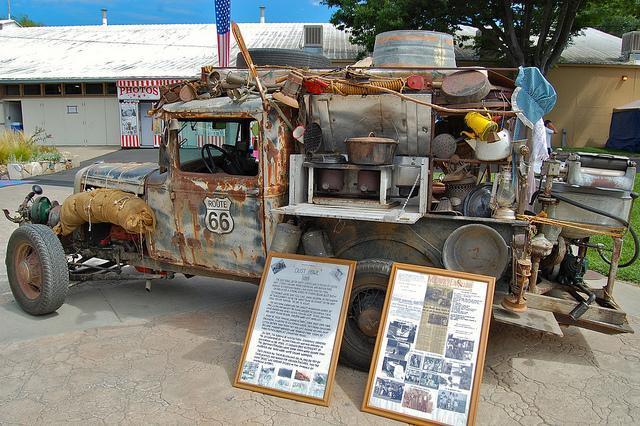How many red cars transporting bicycles to the left are there? there are red cars to the right transporting bicycles too?
Give a very brief answer. 0. 